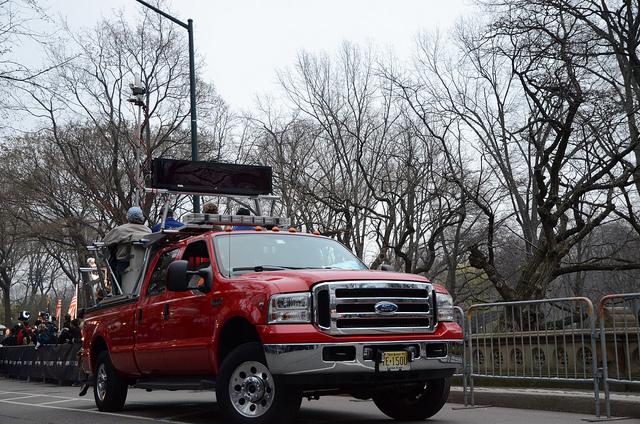Is it summertime?
Answer briefly. No. How many tarps do you see?
Answer briefly. 0. What color is the truck?
Give a very brief answer. Red. What kind of event is going on here?
Short answer required. Parade. 